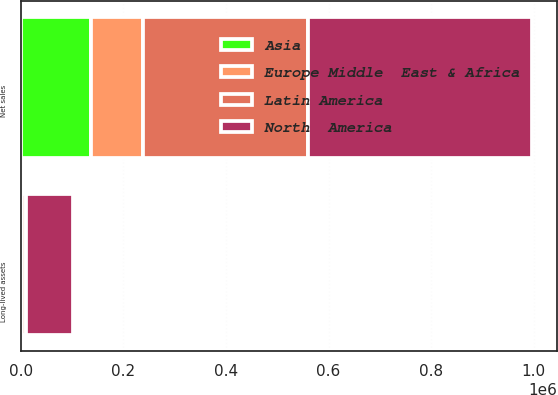<chart> <loc_0><loc_0><loc_500><loc_500><stacked_bar_chart><ecel><fcel>Net sales<fcel>Long-lived assets<nl><fcel>North  America<fcel>435520<fcel>90363<nl><fcel>Latin America<fcel>322970<fcel>7522<nl><fcel>Europe Middle  East & Africa<fcel>100101<fcel>538<nl><fcel>Asia<fcel>137577<fcel>2926<nl></chart> 